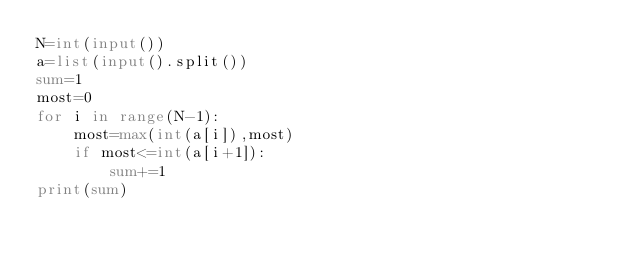Convert code to text. <code><loc_0><loc_0><loc_500><loc_500><_Python_>N=int(input())
a=list(input().split())
sum=1
most=0
for i in range(N-1):
    most=max(int(a[i]),most)
    if most<=int(a[i+1]):
        sum+=1
print(sum)
</code> 